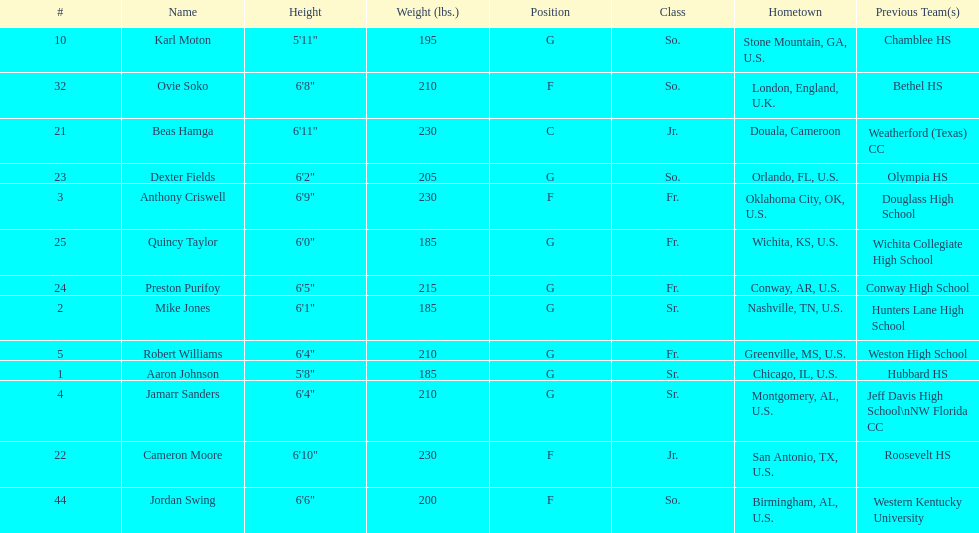Who weighs more, dexter fields or ovie soko? Ovie Soko. 